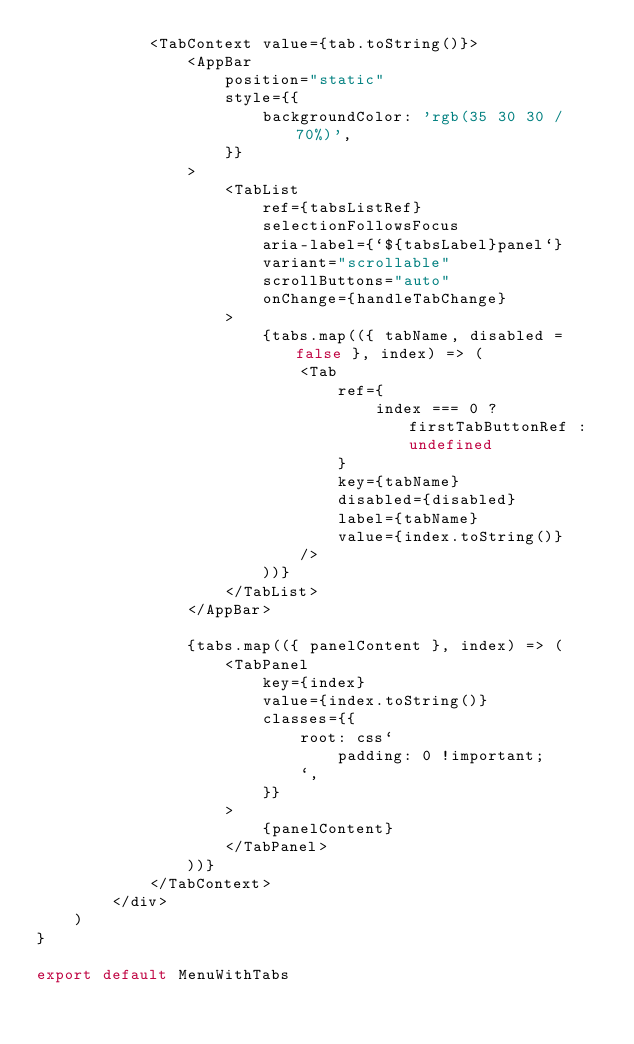Convert code to text. <code><loc_0><loc_0><loc_500><loc_500><_TypeScript_>            <TabContext value={tab.toString()}>
                <AppBar
                    position="static"
                    style={{
                        backgroundColor: 'rgb(35 30 30 / 70%)',
                    }}
                >
                    <TabList
                        ref={tabsListRef}
                        selectionFollowsFocus
                        aria-label={`${tabsLabel}panel`}
                        variant="scrollable"
                        scrollButtons="auto"
                        onChange={handleTabChange}
                    >
                        {tabs.map(({ tabName, disabled = false }, index) => (
                            <Tab
                                ref={
                                    index === 0 ? firstTabButtonRef : undefined
                                }
                                key={tabName}
                                disabled={disabled}
                                label={tabName}
                                value={index.toString()}
                            />
                        ))}
                    </TabList>
                </AppBar>

                {tabs.map(({ panelContent }, index) => (
                    <TabPanel
                        key={index}
                        value={index.toString()}
                        classes={{
                            root: css`
                                padding: 0 !important;
                            `,
                        }}
                    >
                        {panelContent}
                    </TabPanel>
                ))}
            </TabContext>
        </div>
    )
}

export default MenuWithTabs
</code> 